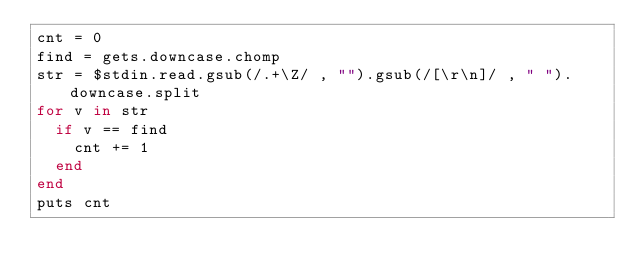Convert code to text. <code><loc_0><loc_0><loc_500><loc_500><_Ruby_>cnt = 0
find = gets.downcase.chomp
str = $stdin.read.gsub(/.+\Z/ , "").gsub(/[\r\n]/ , " ").downcase.split
for v in str
	if v == find
		cnt += 1
	end
end
puts cnt</code> 